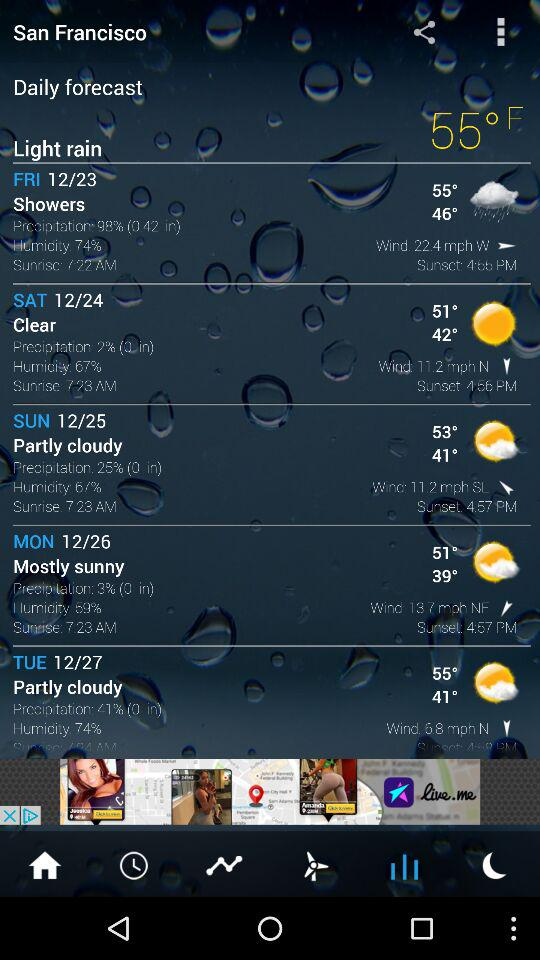What is the humidity on Sunday? The humidity on Sunday is 67%. 